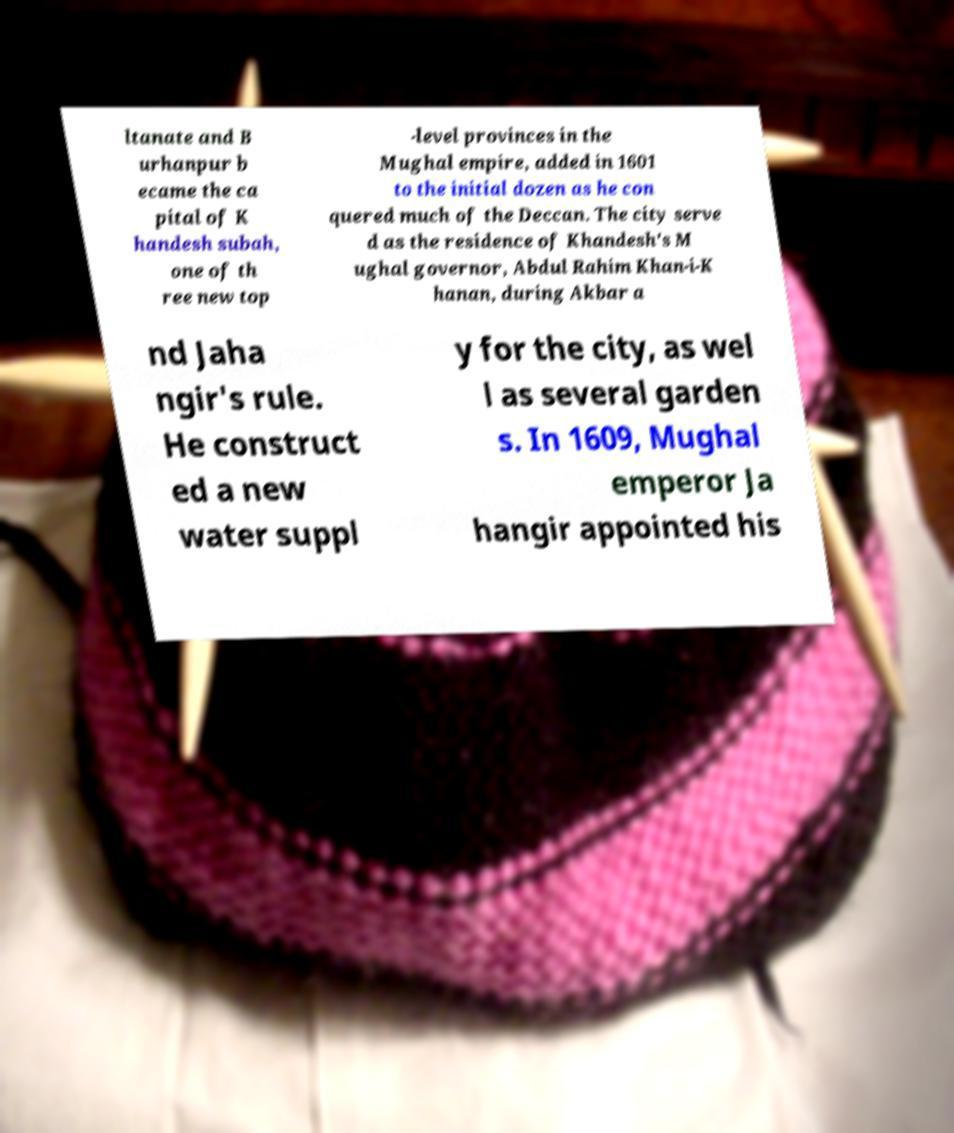Can you accurately transcribe the text from the provided image for me? ltanate and B urhanpur b ecame the ca pital of K handesh subah, one of th ree new top -level provinces in the Mughal empire, added in 1601 to the initial dozen as he con quered much of the Deccan. The city serve d as the residence of Khandesh's M ughal governor, Abdul Rahim Khan-i-K hanan, during Akbar a nd Jaha ngir's rule. He construct ed a new water suppl y for the city, as wel l as several garden s. In 1609, Mughal emperor Ja hangir appointed his 